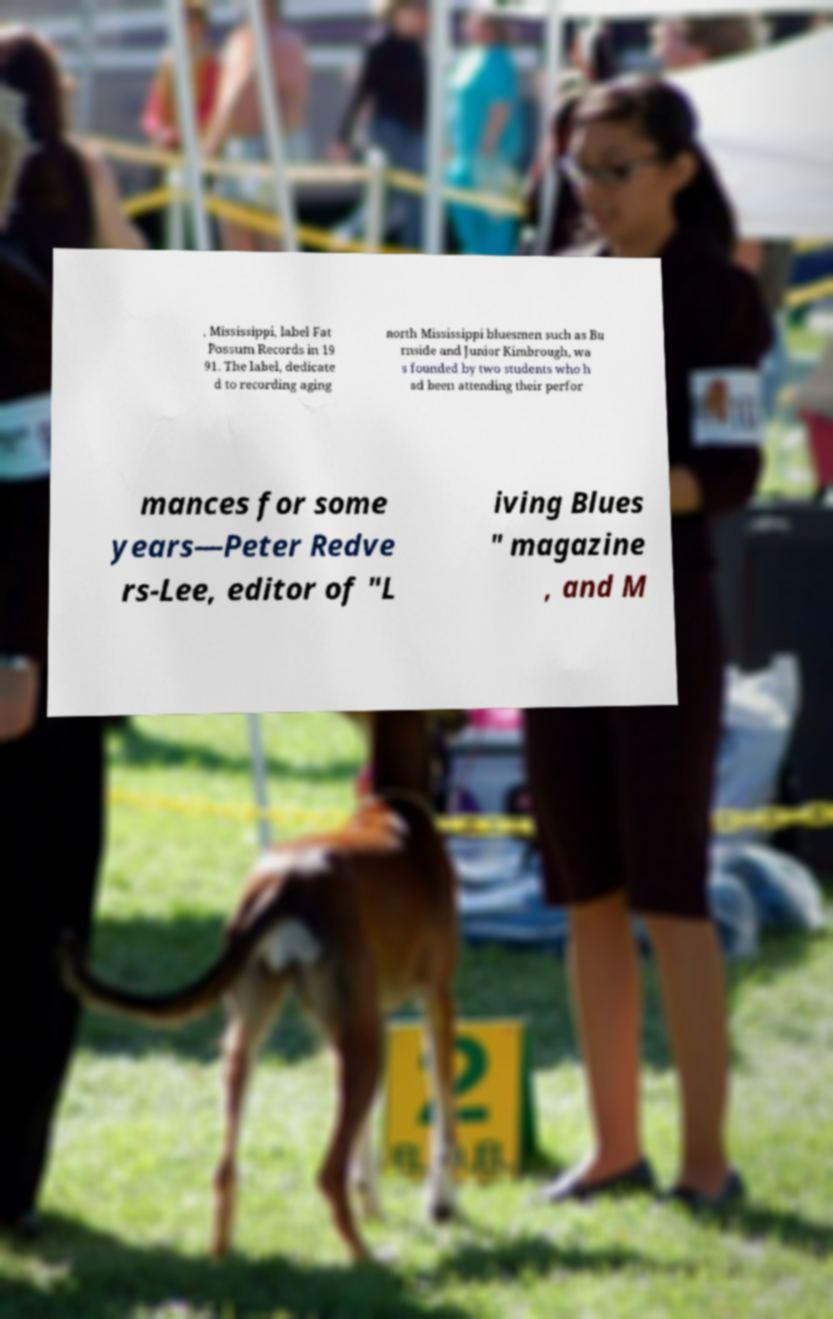Can you read and provide the text displayed in the image?This photo seems to have some interesting text. Can you extract and type it out for me? , Mississippi, label Fat Possum Records in 19 91. The label, dedicate d to recording aging north Mississippi bluesmen such as Bu rnside and Junior Kimbrough, wa s founded by two students who h ad been attending their perfor mances for some years—Peter Redve rs-Lee, editor of "L iving Blues " magazine , and M 